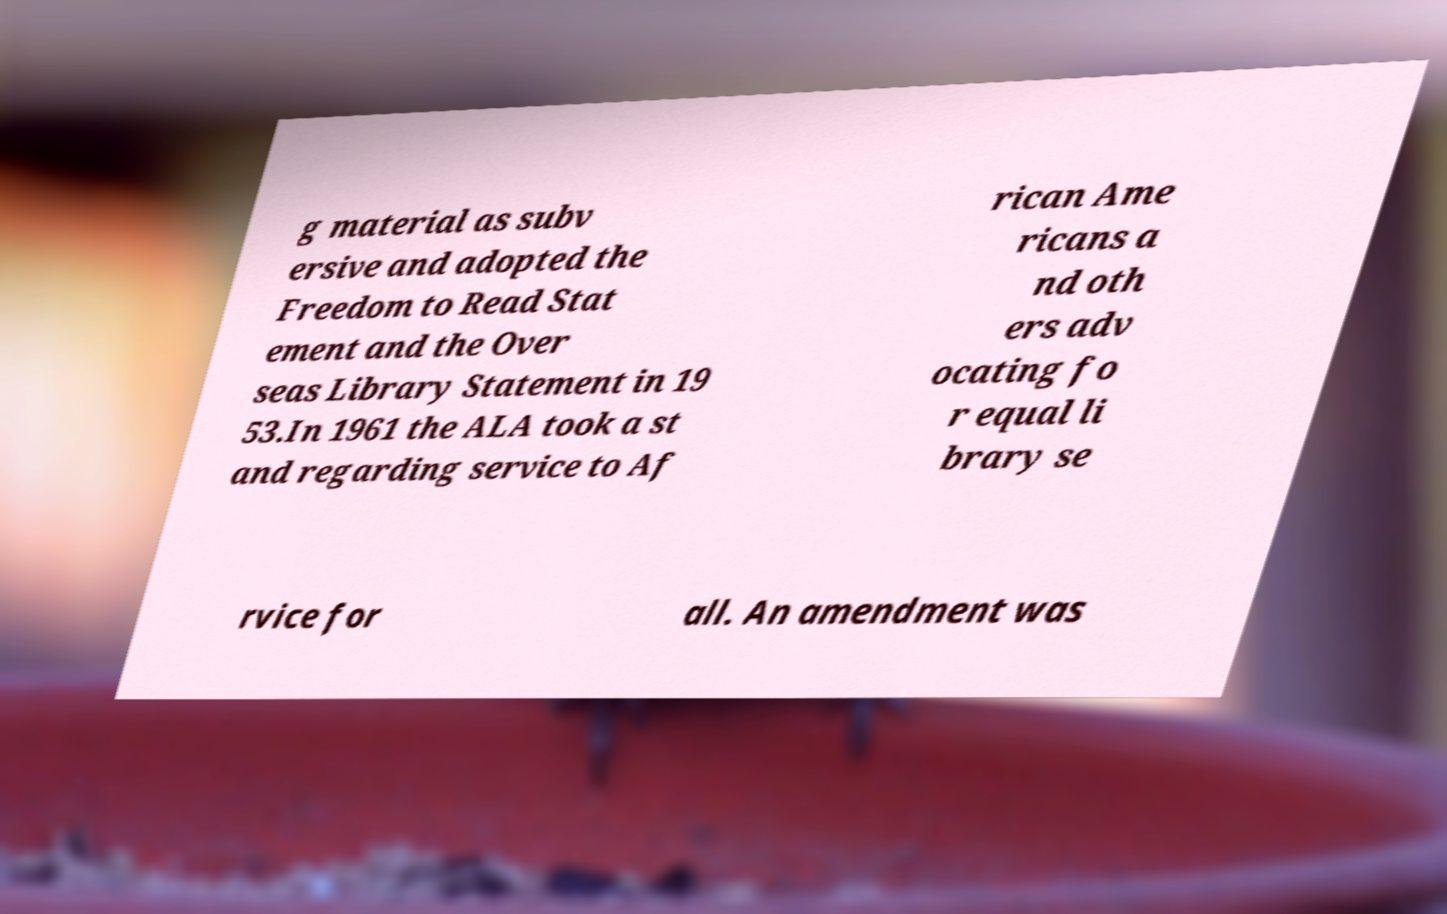Could you assist in decoding the text presented in this image and type it out clearly? g material as subv ersive and adopted the Freedom to Read Stat ement and the Over seas Library Statement in 19 53.In 1961 the ALA took a st and regarding service to Af rican Ame ricans a nd oth ers adv ocating fo r equal li brary se rvice for all. An amendment was 